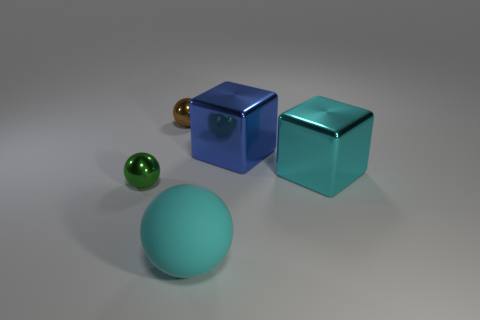Add 5 small brown things. How many objects exist? 10 Subtract all blocks. How many objects are left? 3 Add 4 blue shiny cubes. How many blue shiny cubes are left? 5 Add 3 large blue blocks. How many large blue blocks exist? 4 Subtract 0 brown blocks. How many objects are left? 5 Subtract all green metallic cylinders. Subtract all spheres. How many objects are left? 2 